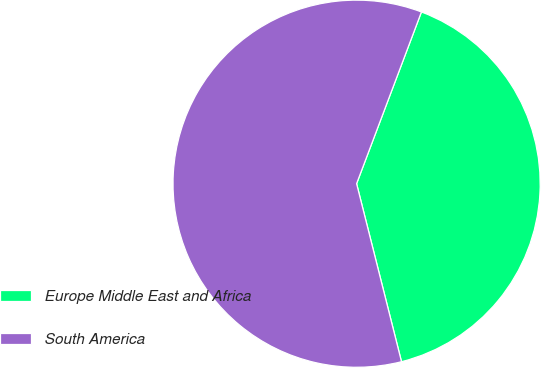Convert chart to OTSL. <chart><loc_0><loc_0><loc_500><loc_500><pie_chart><fcel>Europe Middle East and Africa<fcel>South America<nl><fcel>40.32%<fcel>59.68%<nl></chart> 